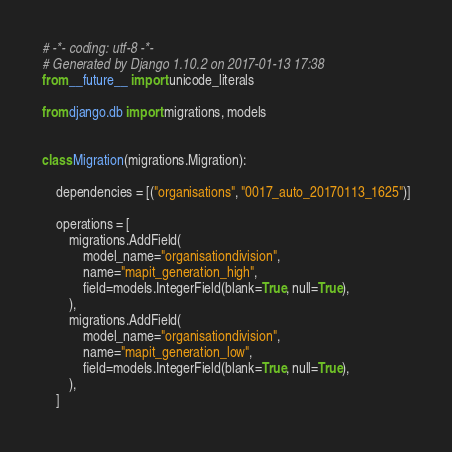Convert code to text. <code><loc_0><loc_0><loc_500><loc_500><_Python_># -*- coding: utf-8 -*-
# Generated by Django 1.10.2 on 2017-01-13 17:38
from __future__ import unicode_literals

from django.db import migrations, models


class Migration(migrations.Migration):

    dependencies = [("organisations", "0017_auto_20170113_1625")]

    operations = [
        migrations.AddField(
            model_name="organisationdivision",
            name="mapit_generation_high",
            field=models.IntegerField(blank=True, null=True),
        ),
        migrations.AddField(
            model_name="organisationdivision",
            name="mapit_generation_low",
            field=models.IntegerField(blank=True, null=True),
        ),
    ]
</code> 